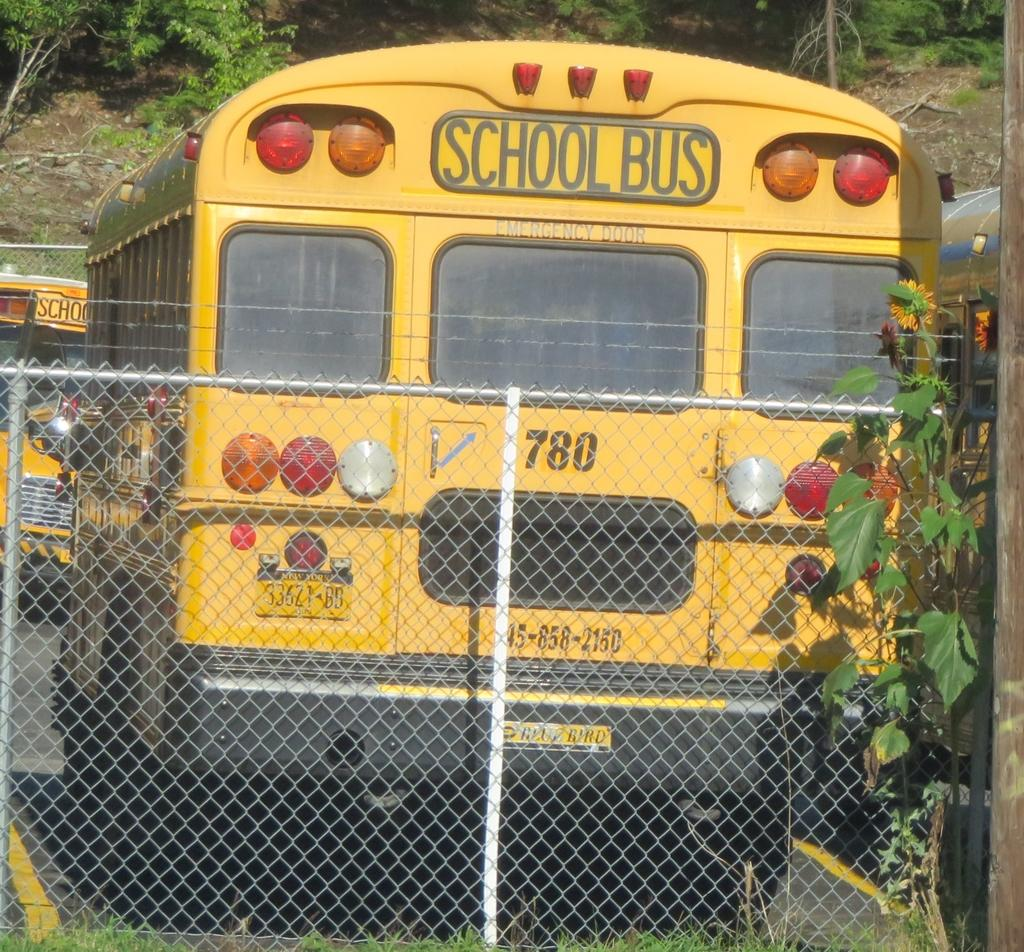What type of vehicles are in the image? There are buses in the image. What features can be seen on the buses? The buses have windows and lights. Is there any text or information on the buses? Yes, there is something written on the buses. What type of barrier is present in the image? There is a mesh fencing in the image. What can be seen on the right side of the image? There is a plant on the right side of the image. What is visible in the background of the image? There are trees in the background of the image. Can you tell me how many frogs are sitting on the buses in the image? There are no frogs present on the buses in the image. What type of fabric is used to cover the seats in the buses? The provided facts do not mention the type of fabric used for the seats in the buses. 